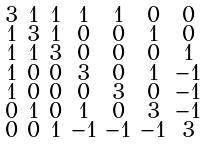Convert formula to latex. <formula><loc_0><loc_0><loc_500><loc_500>\begin{smallmatrix} 3 & 1 & 1 & 1 & 1 & 0 & 0 \\ 1 & 3 & 1 & 0 & 0 & 1 & 0 \\ 1 & 1 & 3 & 0 & 0 & 0 & 1 \\ 1 & 0 & 0 & 3 & 0 & 1 & - 1 \\ 1 & 0 & 0 & 0 & 3 & 0 & - 1 \\ 0 & 1 & 0 & 1 & 0 & 3 & - 1 \\ 0 & 0 & 1 & - 1 & - 1 & - 1 & 3 \end{smallmatrix}</formula> 